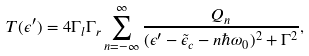<formula> <loc_0><loc_0><loc_500><loc_500>T ( \epsilon ^ { \prime } ) = 4 \Gamma _ { l } \Gamma _ { r } \sum _ { n = - \infty } ^ { \infty } \frac { Q _ { n } } { ( \epsilon ^ { \prime } - \tilde { \epsilon } _ { c } - n \hbar { \omega } _ { 0 } ) ^ { 2 } + \Gamma ^ { 2 } } ,</formula> 